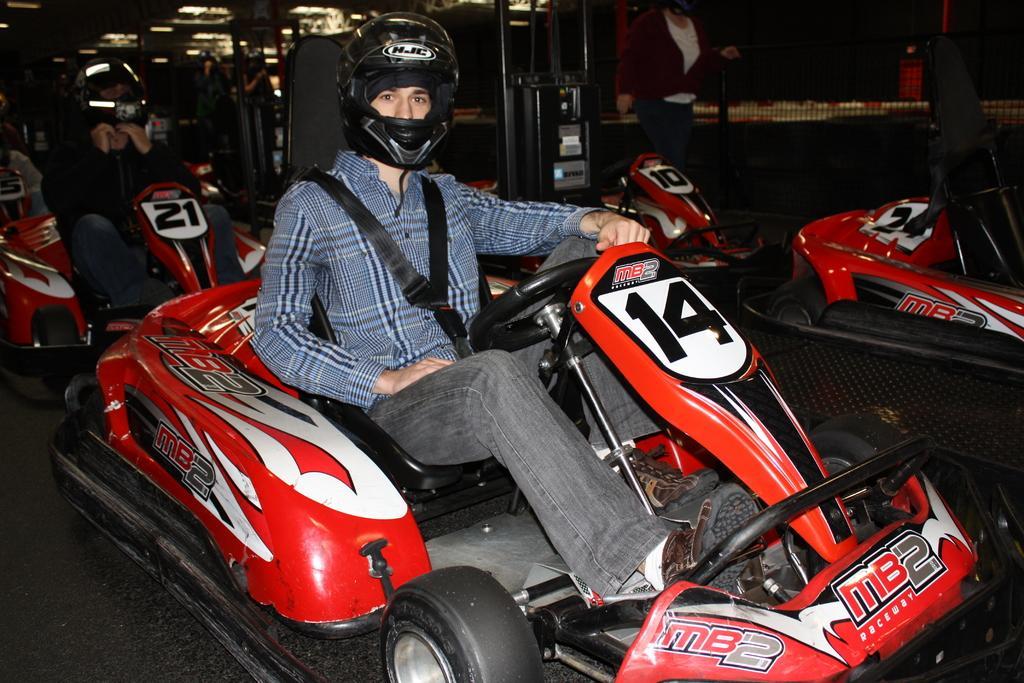Can you describe this image briefly? In the middle of the image two persons are sitting on the vehicles. Beside them there are some vehicles. At the top of the image a person is standing. 